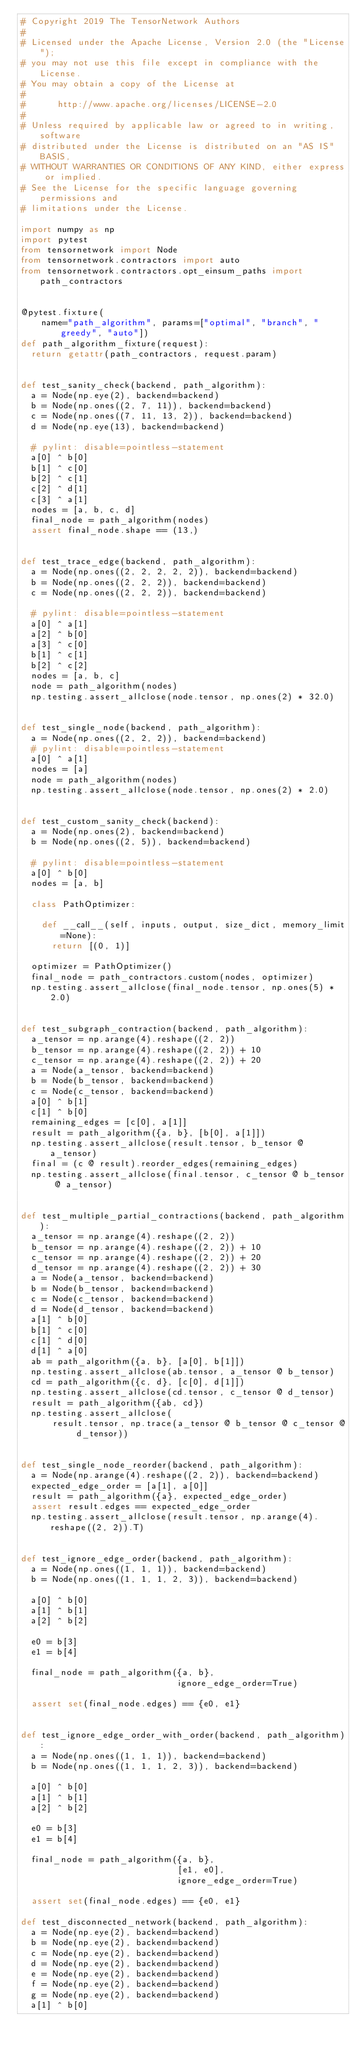Convert code to text. <code><loc_0><loc_0><loc_500><loc_500><_Python_># Copyright 2019 The TensorNetwork Authors
#
# Licensed under the Apache License, Version 2.0 (the "License");
# you may not use this file except in compliance with the License.
# You may obtain a copy of the License at
#
#      http://www.apache.org/licenses/LICENSE-2.0
#
# Unless required by applicable law or agreed to in writing, software
# distributed under the License is distributed on an "AS IS" BASIS,
# WITHOUT WARRANTIES OR CONDITIONS OF ANY KIND, either express or implied.
# See the License for the specific language governing permissions and
# limitations under the License.

import numpy as np
import pytest
from tensornetwork import Node
from tensornetwork.contractors import auto
from tensornetwork.contractors.opt_einsum_paths import path_contractors


@pytest.fixture(
    name="path_algorithm", params=["optimal", "branch", "greedy", "auto"])
def path_algorithm_fixture(request):
  return getattr(path_contractors, request.param)


def test_sanity_check(backend, path_algorithm):
  a = Node(np.eye(2), backend=backend)
  b = Node(np.ones((2, 7, 11)), backend=backend)
  c = Node(np.ones((7, 11, 13, 2)), backend=backend)
  d = Node(np.eye(13), backend=backend)

  # pylint: disable=pointless-statement
  a[0] ^ b[0]
  b[1] ^ c[0]
  b[2] ^ c[1]
  c[2] ^ d[1]
  c[3] ^ a[1]
  nodes = [a, b, c, d]
  final_node = path_algorithm(nodes)
  assert final_node.shape == (13,)


def test_trace_edge(backend, path_algorithm):
  a = Node(np.ones((2, 2, 2, 2, 2)), backend=backend)
  b = Node(np.ones((2, 2, 2)), backend=backend)
  c = Node(np.ones((2, 2, 2)), backend=backend)

  # pylint: disable=pointless-statement
  a[0] ^ a[1]
  a[2] ^ b[0]
  a[3] ^ c[0]
  b[1] ^ c[1]
  b[2] ^ c[2]
  nodes = [a, b, c]
  node = path_algorithm(nodes)
  np.testing.assert_allclose(node.tensor, np.ones(2) * 32.0)


def test_single_node(backend, path_algorithm):
  a = Node(np.ones((2, 2, 2)), backend=backend)
  # pylint: disable=pointless-statement
  a[0] ^ a[1]
  nodes = [a]
  node = path_algorithm(nodes)
  np.testing.assert_allclose(node.tensor, np.ones(2) * 2.0)


def test_custom_sanity_check(backend):
  a = Node(np.ones(2), backend=backend)
  b = Node(np.ones((2, 5)), backend=backend)

  # pylint: disable=pointless-statement
  a[0] ^ b[0]
  nodes = [a, b]

  class PathOptimizer:

    def __call__(self, inputs, output, size_dict, memory_limit=None):
      return [(0, 1)]

  optimizer = PathOptimizer()
  final_node = path_contractors.custom(nodes, optimizer)
  np.testing.assert_allclose(final_node.tensor, np.ones(5) * 2.0)


def test_subgraph_contraction(backend, path_algorithm):
  a_tensor = np.arange(4).reshape((2, 2))
  b_tensor = np.arange(4).reshape((2, 2)) + 10
  c_tensor = np.arange(4).reshape((2, 2)) + 20
  a = Node(a_tensor, backend=backend)
  b = Node(b_tensor, backend=backend)
  c = Node(c_tensor, backend=backend)
  a[0] ^ b[1]
  c[1] ^ b[0]
  remaining_edges = [c[0], a[1]]
  result = path_algorithm({a, b}, [b[0], a[1]])
  np.testing.assert_allclose(result.tensor, b_tensor @ a_tensor)
  final = (c @ result).reorder_edges(remaining_edges)
  np.testing.assert_allclose(final.tensor, c_tensor @ b_tensor @ a_tensor)


def test_multiple_partial_contractions(backend, path_algorithm):
  a_tensor = np.arange(4).reshape((2, 2))
  b_tensor = np.arange(4).reshape((2, 2)) + 10
  c_tensor = np.arange(4).reshape((2, 2)) + 20
  d_tensor = np.arange(4).reshape((2, 2)) + 30
  a = Node(a_tensor, backend=backend)
  b = Node(b_tensor, backend=backend)
  c = Node(c_tensor, backend=backend)
  d = Node(d_tensor, backend=backend)
  a[1] ^ b[0]
  b[1] ^ c[0]
  c[1] ^ d[0]
  d[1] ^ a[0]
  ab = path_algorithm({a, b}, [a[0], b[1]])
  np.testing.assert_allclose(ab.tensor, a_tensor @ b_tensor)
  cd = path_algorithm({c, d}, [c[0], d[1]])
  np.testing.assert_allclose(cd.tensor, c_tensor @ d_tensor)
  result = path_algorithm({ab, cd})
  np.testing.assert_allclose(
      result.tensor, np.trace(a_tensor @ b_tensor @ c_tensor @ d_tensor))


def test_single_node_reorder(backend, path_algorithm):
  a = Node(np.arange(4).reshape((2, 2)), backend=backend)
  expected_edge_order = [a[1], a[0]]
  result = path_algorithm({a}, expected_edge_order)
  assert result.edges == expected_edge_order
  np.testing.assert_allclose(result.tensor, np.arange(4).reshape((2, 2)).T)


def test_ignore_edge_order(backend, path_algorithm):
  a = Node(np.ones((1, 1, 1)), backend=backend)
  b = Node(np.ones((1, 1, 1, 2, 3)), backend=backend)

  a[0] ^ b[0]
  a[1] ^ b[1]
  a[2] ^ b[2]

  e0 = b[3]
  e1 = b[4]

  final_node = path_algorithm({a, b},
                              ignore_edge_order=True)

  assert set(final_node.edges) == {e0, e1}


def test_ignore_edge_order_with_order(backend, path_algorithm):
  a = Node(np.ones((1, 1, 1)), backend=backend)
  b = Node(np.ones((1, 1, 1, 2, 3)), backend=backend)

  a[0] ^ b[0]
  a[1] ^ b[1]
  a[2] ^ b[2]

  e0 = b[3]
  e1 = b[4]

  final_node = path_algorithm({a, b},
                              [e1, e0],
                              ignore_edge_order=True)

  assert set(final_node.edges) == {e0, e1}

def test_disconnected_network(backend, path_algorithm):
  a = Node(np.eye(2), backend=backend)
  b = Node(np.eye(2), backend=backend)
  c = Node(np.eye(2), backend=backend)
  d = Node(np.eye(2), backend=backend)
  e = Node(np.eye(2), backend=backend)
  f = Node(np.eye(2), backend=backend)
  g = Node(np.eye(2), backend=backend)
  a[1] ^ b[0]</code> 